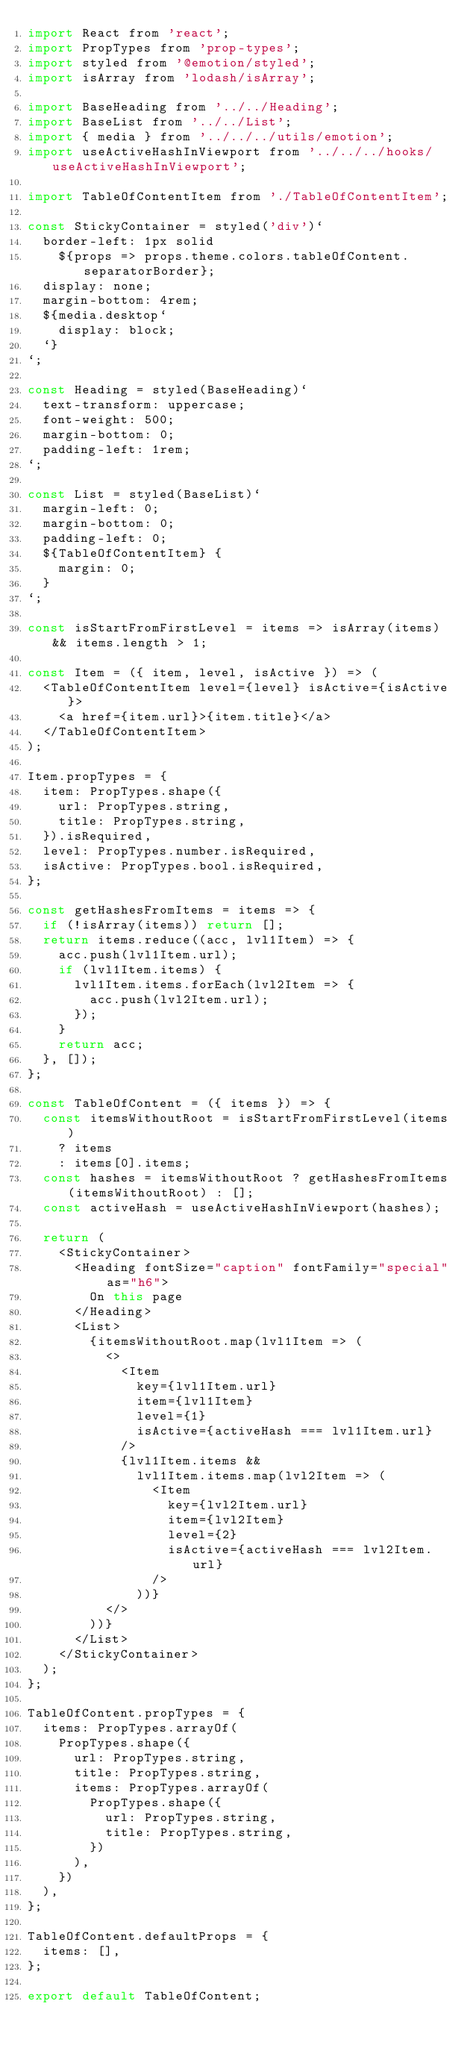<code> <loc_0><loc_0><loc_500><loc_500><_JavaScript_>import React from 'react';
import PropTypes from 'prop-types';
import styled from '@emotion/styled';
import isArray from 'lodash/isArray';

import BaseHeading from '../../Heading';
import BaseList from '../../List';
import { media } from '../../../utils/emotion';
import useActiveHashInViewport from '../../../hooks/useActiveHashInViewport';

import TableOfContentItem from './TableOfContentItem';

const StickyContainer = styled('div')`
  border-left: 1px solid
    ${props => props.theme.colors.tableOfContent.separatorBorder};
  display: none;
  margin-bottom: 4rem;
  ${media.desktop`
    display: block;
  `}
`;

const Heading = styled(BaseHeading)`
  text-transform: uppercase;
  font-weight: 500;
  margin-bottom: 0;
  padding-left: 1rem;
`;

const List = styled(BaseList)`
  margin-left: 0;
  margin-bottom: 0;
  padding-left: 0;
  ${TableOfContentItem} {
    margin: 0;
  }
`;

const isStartFromFirstLevel = items => isArray(items) && items.length > 1;

const Item = ({ item, level, isActive }) => (
  <TableOfContentItem level={level} isActive={isActive}>
    <a href={item.url}>{item.title}</a>
  </TableOfContentItem>
);

Item.propTypes = {
  item: PropTypes.shape({
    url: PropTypes.string,
    title: PropTypes.string,
  }).isRequired,
  level: PropTypes.number.isRequired,
  isActive: PropTypes.bool.isRequired,
};

const getHashesFromItems = items => {
  if (!isArray(items)) return [];
  return items.reduce((acc, lvl1Item) => {
    acc.push(lvl1Item.url);
    if (lvl1Item.items) {
      lvl1Item.items.forEach(lvl2Item => {
        acc.push(lvl2Item.url);
      });
    }
    return acc;
  }, []);
};

const TableOfContent = ({ items }) => {
  const itemsWithoutRoot = isStartFromFirstLevel(items)
    ? items
    : items[0].items;
  const hashes = itemsWithoutRoot ? getHashesFromItems(itemsWithoutRoot) : [];
  const activeHash = useActiveHashInViewport(hashes);

  return (
    <StickyContainer>
      <Heading fontSize="caption" fontFamily="special" as="h6">
        On this page
      </Heading>
      <List>
        {itemsWithoutRoot.map(lvl1Item => (
          <>
            <Item
              key={lvl1Item.url}
              item={lvl1Item}
              level={1}
              isActive={activeHash === lvl1Item.url}
            />
            {lvl1Item.items &&
              lvl1Item.items.map(lvl2Item => (
                <Item
                  key={lvl2Item.url}
                  item={lvl2Item}
                  level={2}
                  isActive={activeHash === lvl2Item.url}
                />
              ))}
          </>
        ))}
      </List>
    </StickyContainer>
  );
};

TableOfContent.propTypes = {
  items: PropTypes.arrayOf(
    PropTypes.shape({
      url: PropTypes.string,
      title: PropTypes.string,
      items: PropTypes.arrayOf(
        PropTypes.shape({
          url: PropTypes.string,
          title: PropTypes.string,
        })
      ),
    })
  ),
};

TableOfContent.defaultProps = {
  items: [],
};

export default TableOfContent;
</code> 